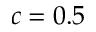Convert formula to latex. <formula><loc_0><loc_0><loc_500><loc_500>c = 0 . 5</formula> 